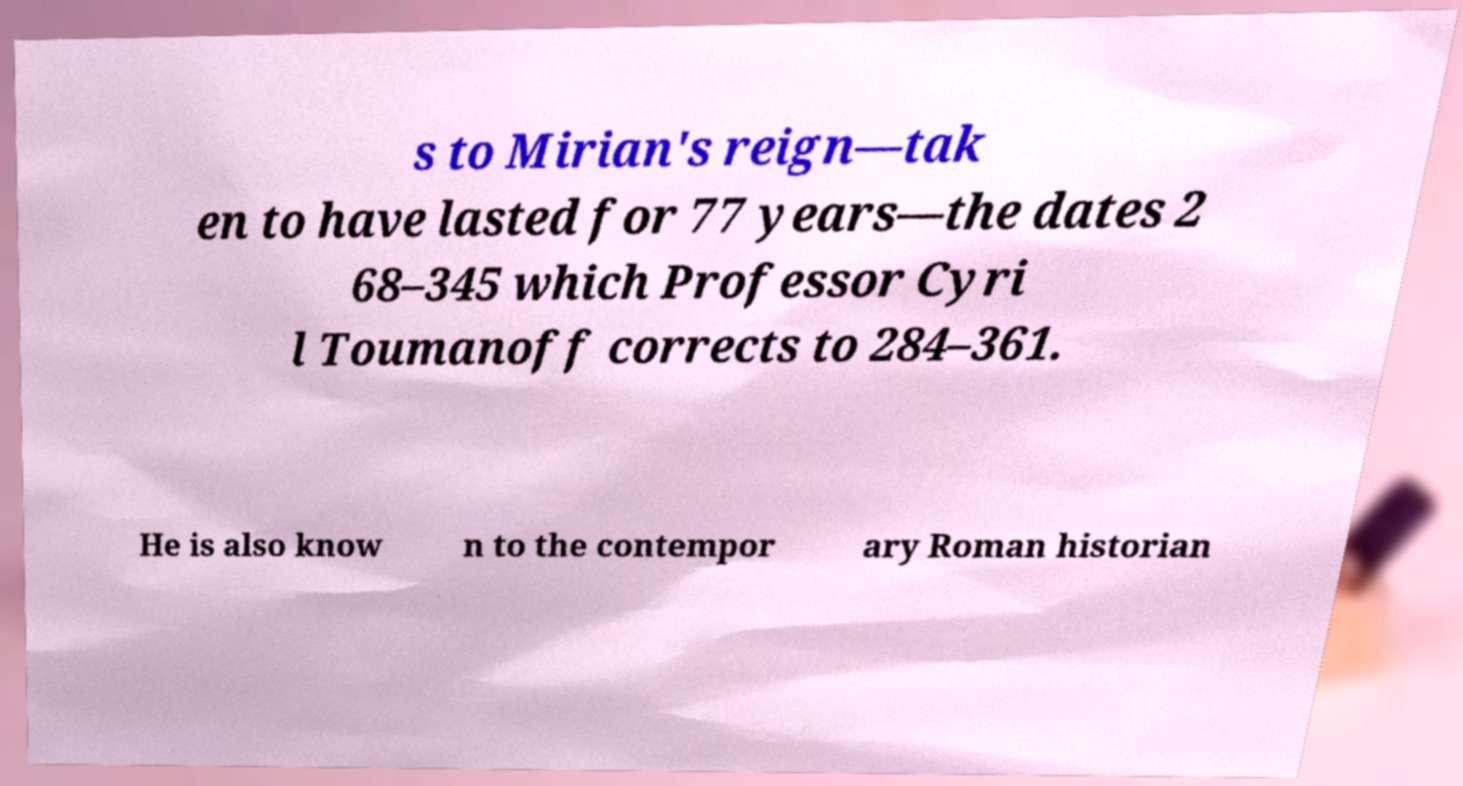I need the written content from this picture converted into text. Can you do that? s to Mirian's reign—tak en to have lasted for 77 years—the dates 2 68–345 which Professor Cyri l Toumanoff corrects to 284–361. He is also know n to the contempor ary Roman historian 